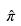<formula> <loc_0><loc_0><loc_500><loc_500>\hat { \pi }</formula> 